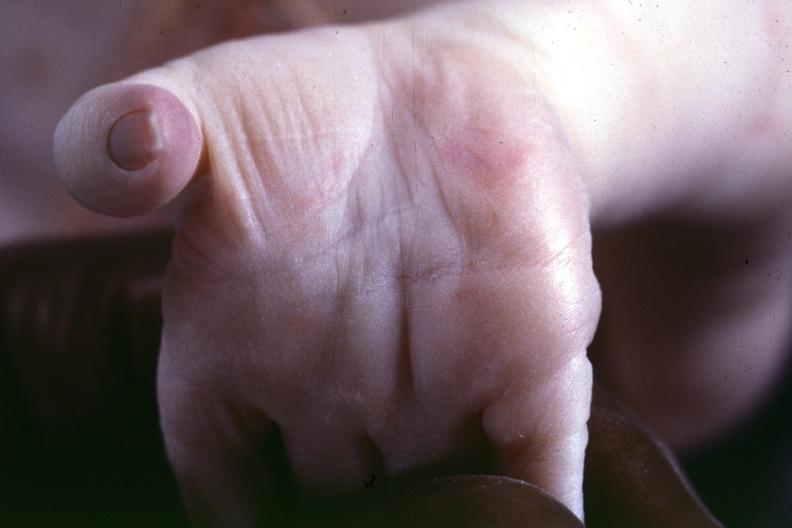what was taken from another case to illustrate the difference?
Answer the question using a single word or phrase. This 